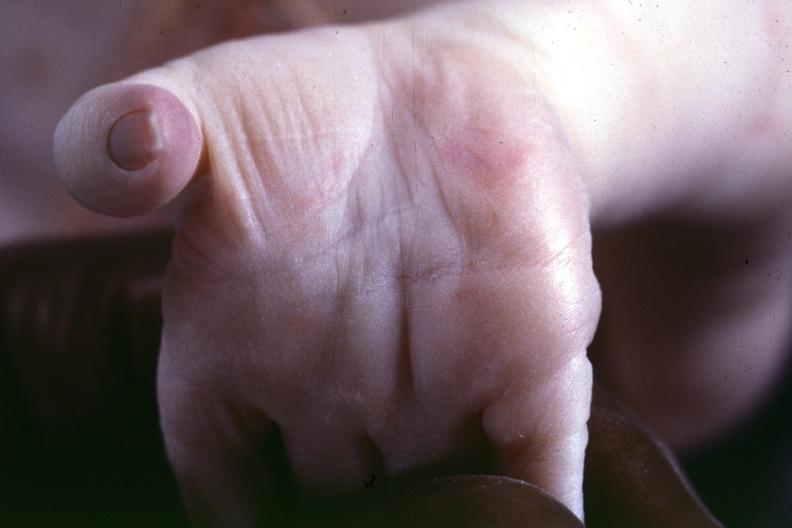what was taken from another case to illustrate the difference?
Answer the question using a single word or phrase. This 